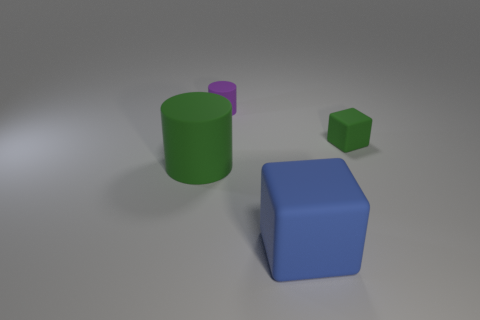What colors are the objects in the image? The objects displayed in the image include a green cylinder, a blue cube, and a smaller green cube. 